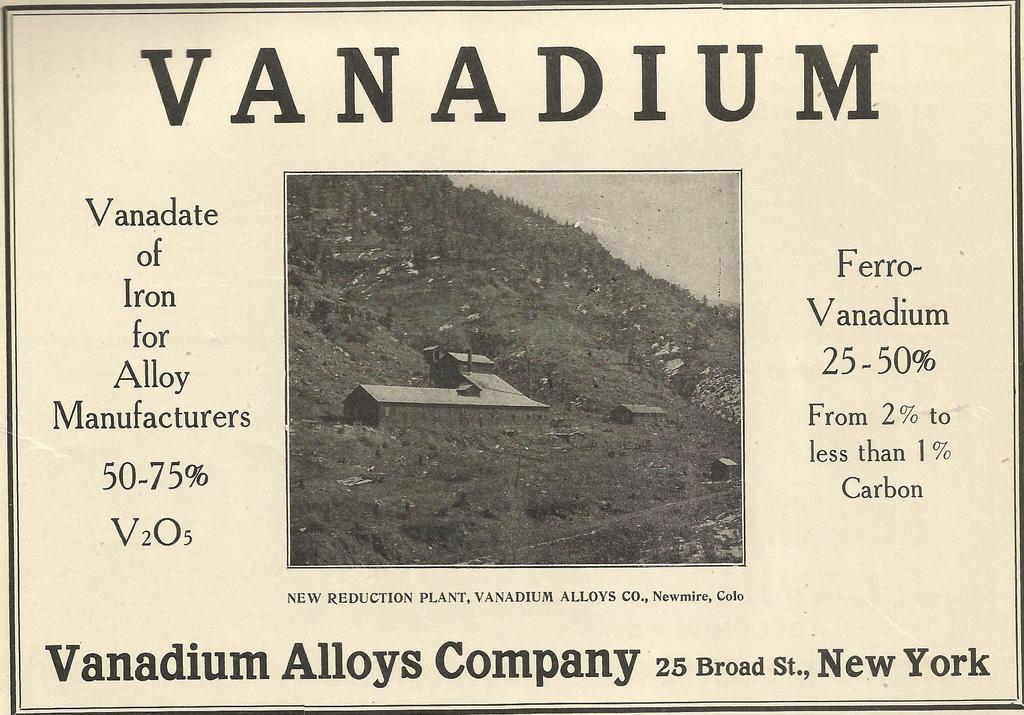Describe this image in one or two sentences. There is a black and white picture of a hill with homes in front of with text all around it on a poster. 